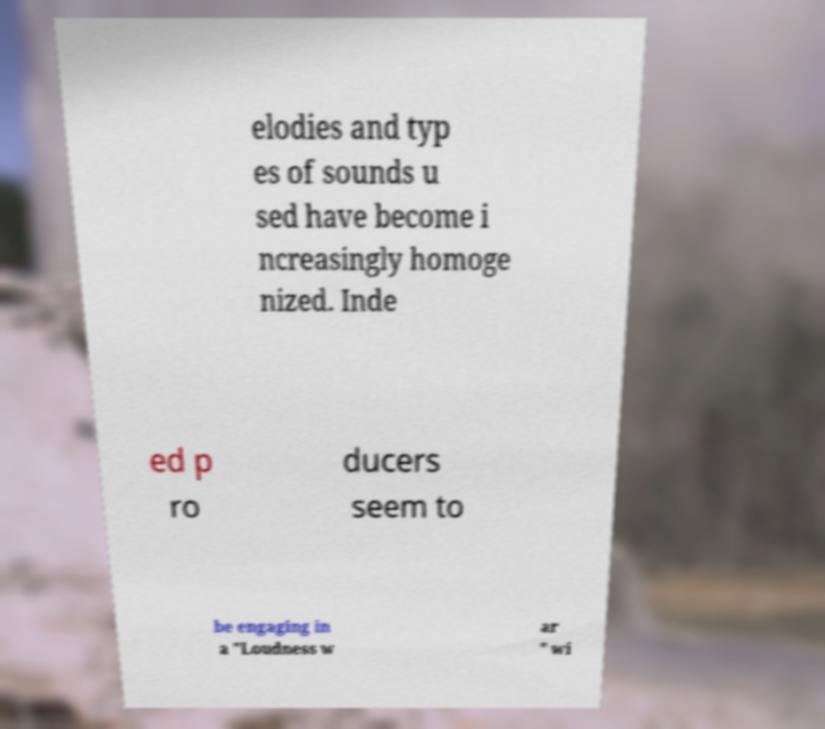Can you accurately transcribe the text from the provided image for me? elodies and typ es of sounds u sed have become i ncreasingly homoge nized. Inde ed p ro ducers seem to be engaging in a "Loudness w ar " wi 